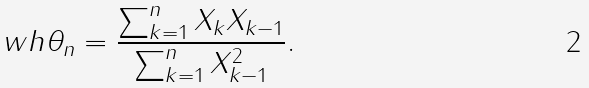<formula> <loc_0><loc_0><loc_500><loc_500>\ w h { \theta } _ { n } = \frac { \sum _ { k = 1 } ^ { n } X _ { k } X _ { k - 1 } } { \sum _ { k = 1 } ^ { n } X _ { k - 1 } ^ { 2 } } .</formula> 